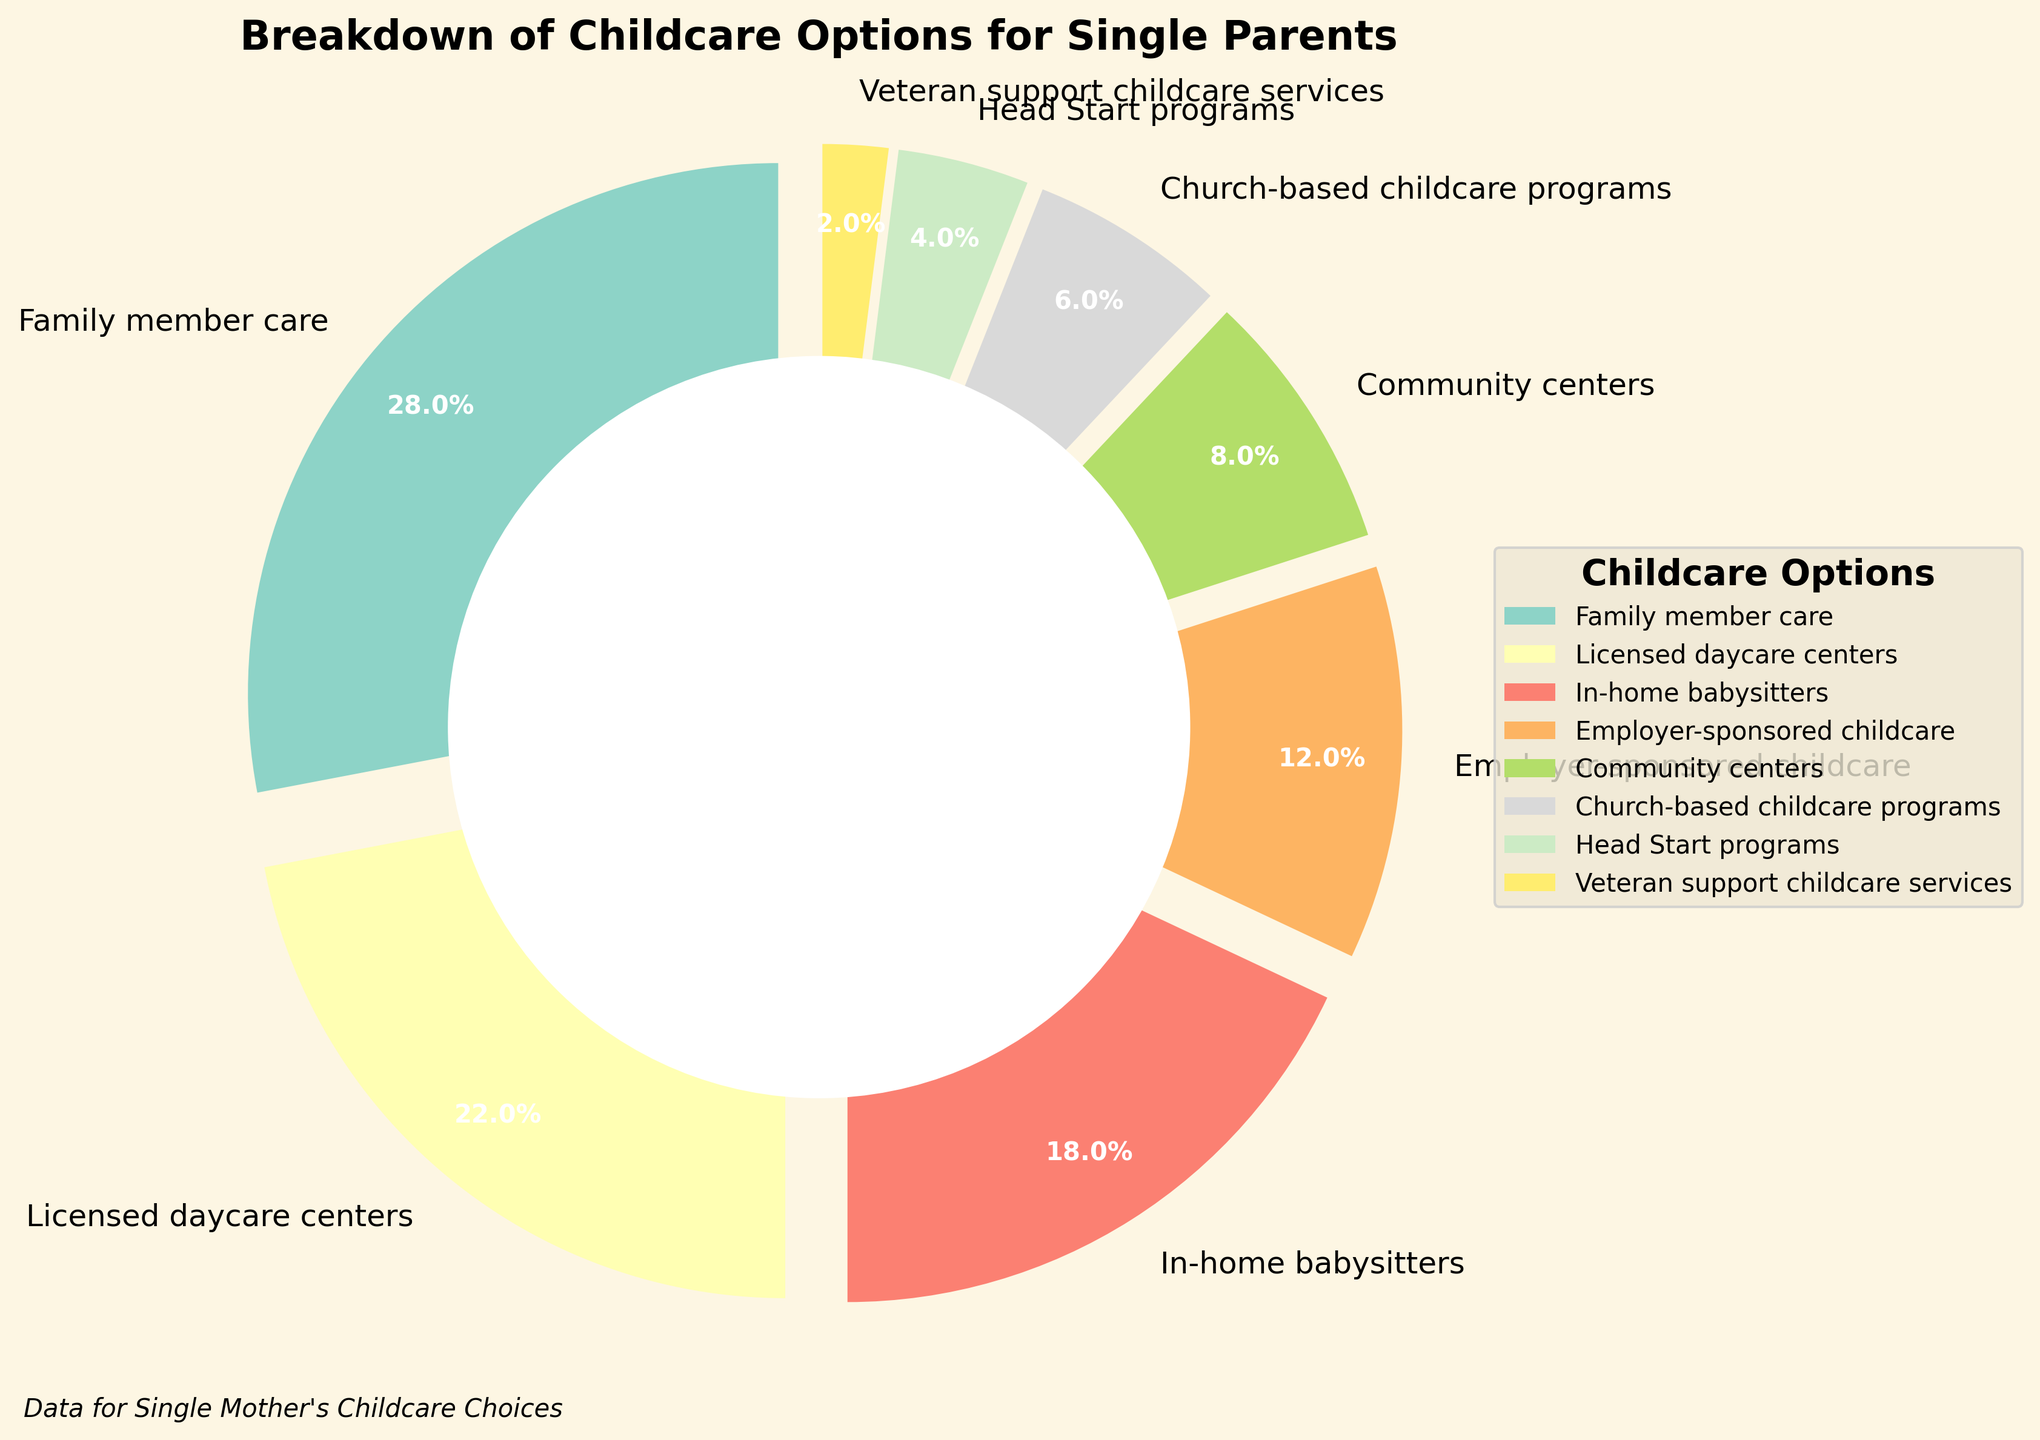What's the largest childcare option for single parents? The figure shows that "Family member care" has the largest wedge with 28%, which is the highest among all options.
Answer: Family member care Which childcare option has the smallest percentage? The smallest wedge in the pie chart represents "Veteran support childcare services," which is 2%.
Answer: Veteran support childcare services How much larger is the percentage for Licensed daycare centers compared to Church-based childcare programs? The percentage for Licensed daycare centers is 22%, and for Church-based childcare programs it is 6%. The difference is 22% - 6% = 16%.
Answer: 16% What is the combined percentage for Community centers and Church-based childcare programs? The figure shows Community centers at 8% and Church-based childcare programs at 6%. Combined, it is 8% + 6% = 14%.
Answer: 14% Compare the childcare option percentage for In-home babysitters to that of Employer-sponsored childcare and determine which is higher. In-home babysitters have a percentage of 18%, while Employer-sponsored childcare is at 12%. Since 18% is greater than 12%, In-home babysitters are higher.
Answer: In-home babysitters What is the total percentage of options that are below 10%? Options below 10% are Community centers (8%), Church-based childcare programs (6%), Head Start programs (4%), and Veteran support childcare services (2%). Summing these, 8% + 6% + 4% + 2% = 20%.
Answer: 20% How many childcare options have percentages greater than 15%? The figure shows that Family member care (28%), Licensed daycare centers (22%), and In-home babysitters (18%) have percentages greater than 15%. There are 3 such options.
Answer: 3 What is the difference between the percentage for Family member care and Head Start programs? Family member care is at 28% and Head Start programs are at 4%. The difference is 28% - 4% = 24%.
Answer: 24% What is the average percentage of all childcare options? To find the average, sum all percentages and divide by the number of options. The sum is 28% + 22% + 18% + 12% + 8% + 6% + 4% + 2% = 100%. There are 8 options. The average is 100% / 8 = 12.5%.
Answer: 12.5% In  one sentence, compare the portions represented by the options with the three highest percentages. The options with the three highest percentages are Family member care (28%), Licensed daycare centers (22%), and In-home babysitters (18%); Family member care has the largest portion, followed by Licensed daycare centers, and then In-home babysitters.
Answer: Family member care > Licensed daycare centers > In-home babysitters 